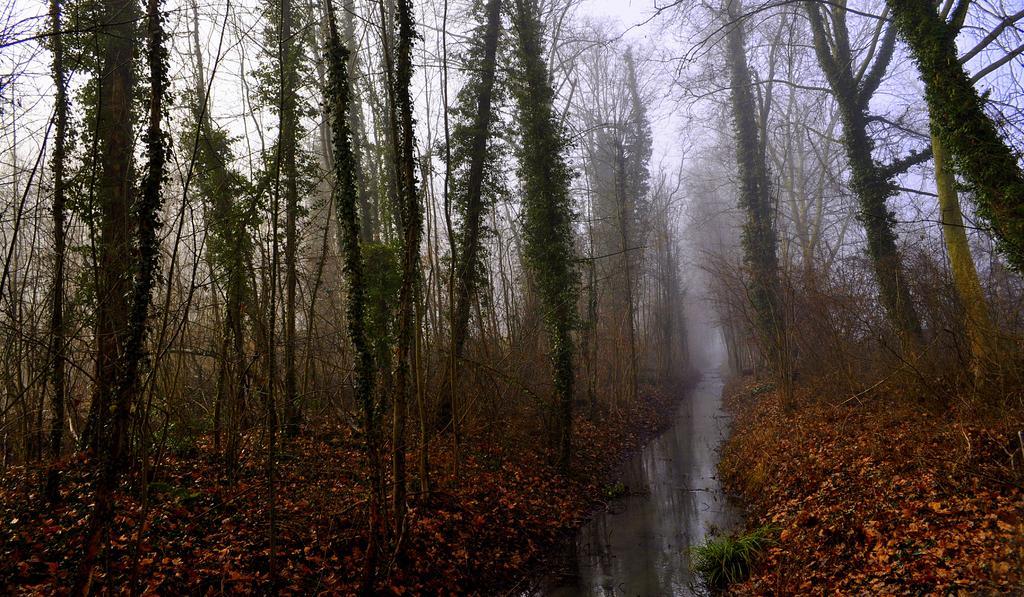Describe this image in one or two sentences. This is an outside view. At the bottom of the image there is a lake. On both sides of the lake there are many dry leaves on the ground. Here I can see many trees. In the background, I can see the sky. 